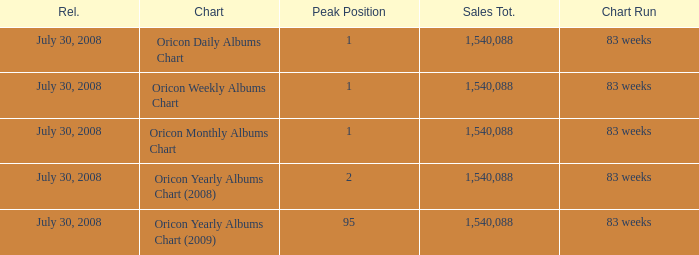How much Peak Position has Sales Total larger than 1,540,088? 0.0. 